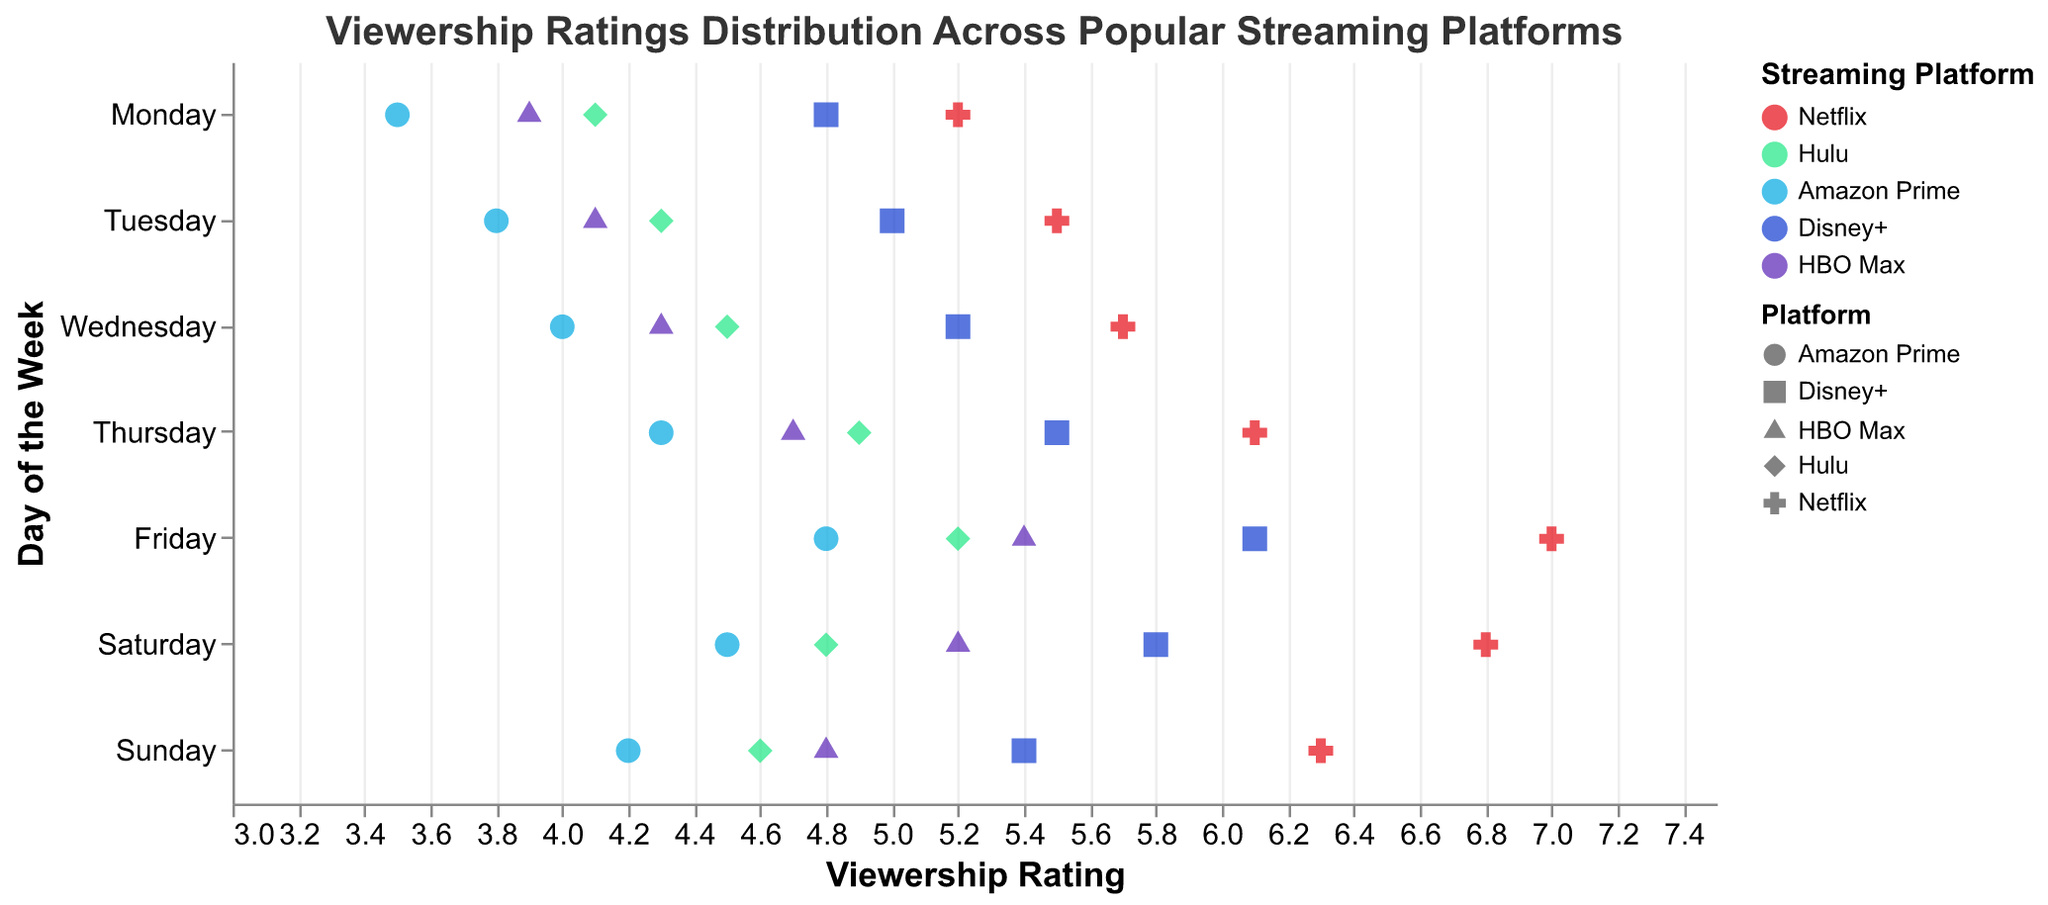What is the title of the figure? The title is displayed at the top of the figure. It reads "Viewership Ratings Distribution Across Popular Streaming Platforms."
Answer: Viewership Ratings Distribution Across Popular Streaming Platforms Which streaming platform has the highest viewership rating on Friday? On the x-axis for Friday, the highest rating point belongs to Netflix with a rating of 7.0.
Answer: Netflix What is the color used to represent Disney+ in the figure? Disney+ is represented with the color blue in the figure, as indicated by the legend.
Answer: blue What shape represents Amazon Prime in the plot? Amazon Prime is represented by triangles according to the shape encoding in the plot's legend.
Answer: triangle On which day does HBO Max have its highest viewership rating? By examining the rating points for HBO Max on each day, the highest rating appears on Friday with a value of 5.4.
Answer: Friday What is the average viewership rating for Netflix across the week? Add up the ratings for Netflix from Monday to Sunday (5.2 + 5.5 + 5.7 + 6.1 + 7.0 + 6.8 + 6.3) and divide by 7. (42.6 / 7 = 6.09)
Answer: 6.09 How does Hulu’s viewership rating on Wednesday compare to its rating on Monday? On Wednesday, Hulu’s rating is 4.5, which is higher than its rating on Monday (4.1).
Answer: Wednesday: 4.5, Monday: 4.1 Which day has the widest range of viewership ratings across all platforms? The range is the difference between the highest and lowest ratings for each day. Friday has the range from 3.5 (Amazon Prime) to 7.0 (Netflix), giving a range of 3.5. This is higher than the ranges for other days.
Answer: Friday Which streaming platform has the most consistent (narrowest range) viewership ratings across the week? Calculate the range of ratings for each platform from Monday to Sunday. Hulu’s ratings range from 4.1 to 5.2, giving a range of 1.1, which is the narrowest compared to other platforms.
Answer: Hulu How do Disney+ ratings compare from Monday to Thursday? Disney+ ratings are as follows: Monday (4.8), Tuesday (5.0), Wednesday (5.2), Thursday (5.5). There is a gradual increase from Monday to Thursday.
Answer: Increased gradually 